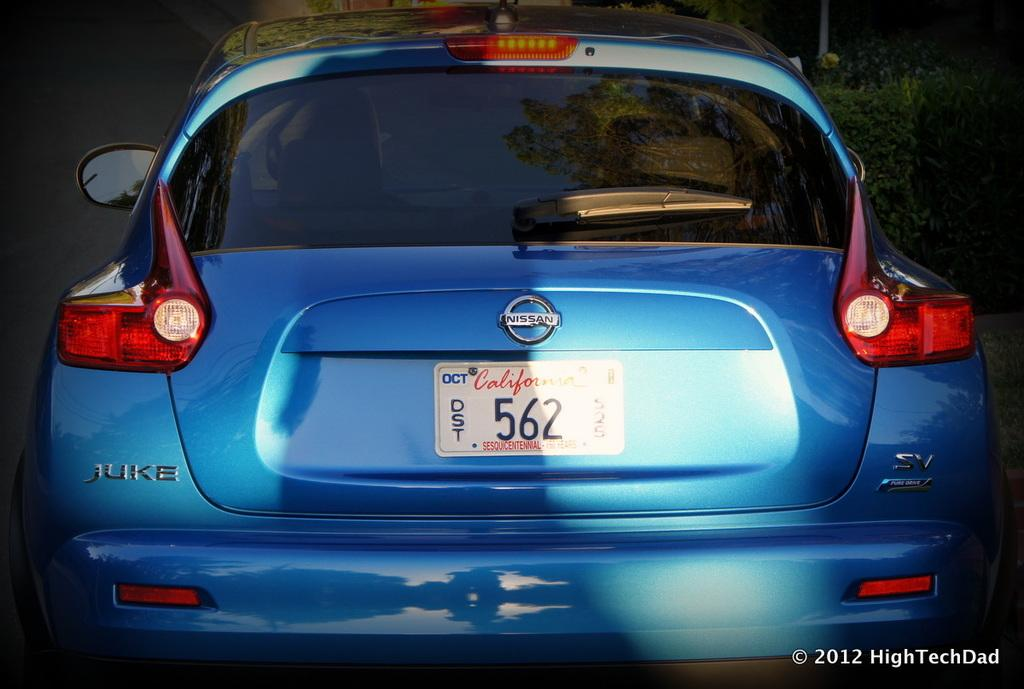<image>
Describe the image concisely. A Nissan Juke car with California tags in baby blue. 